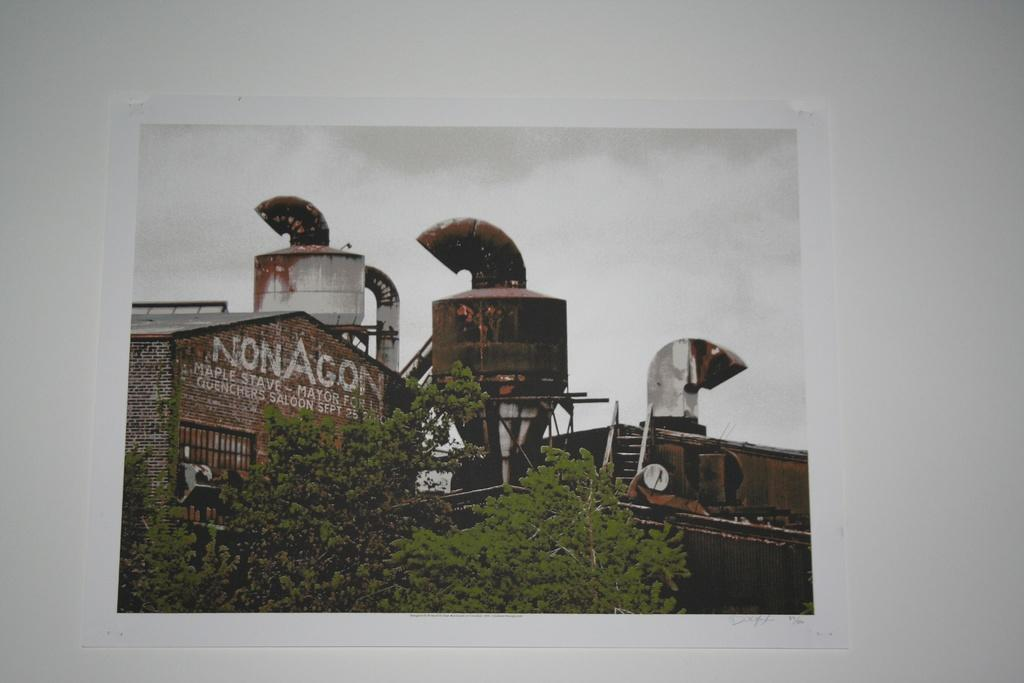<image>
Share a concise interpretation of the image provided. A brick building has NonAgon on it in white lettering. 